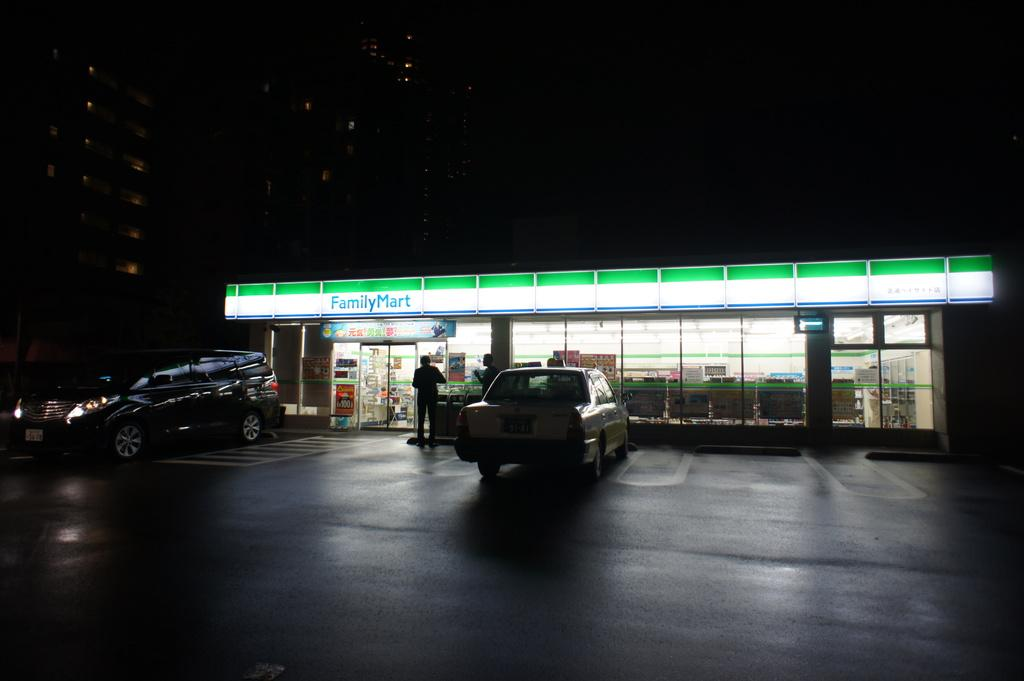<image>
Summarize the visual content of the image. Two people are standing outside a Family Mart store. 